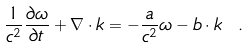<formula> <loc_0><loc_0><loc_500><loc_500>\frac { 1 } { c ^ { 2 } } \frac { \partial \omega } { \partial t } + \nabla \cdot { k } = - \frac { a } { c ^ { 2 } } \omega - { b } \cdot { k } \ .</formula> 